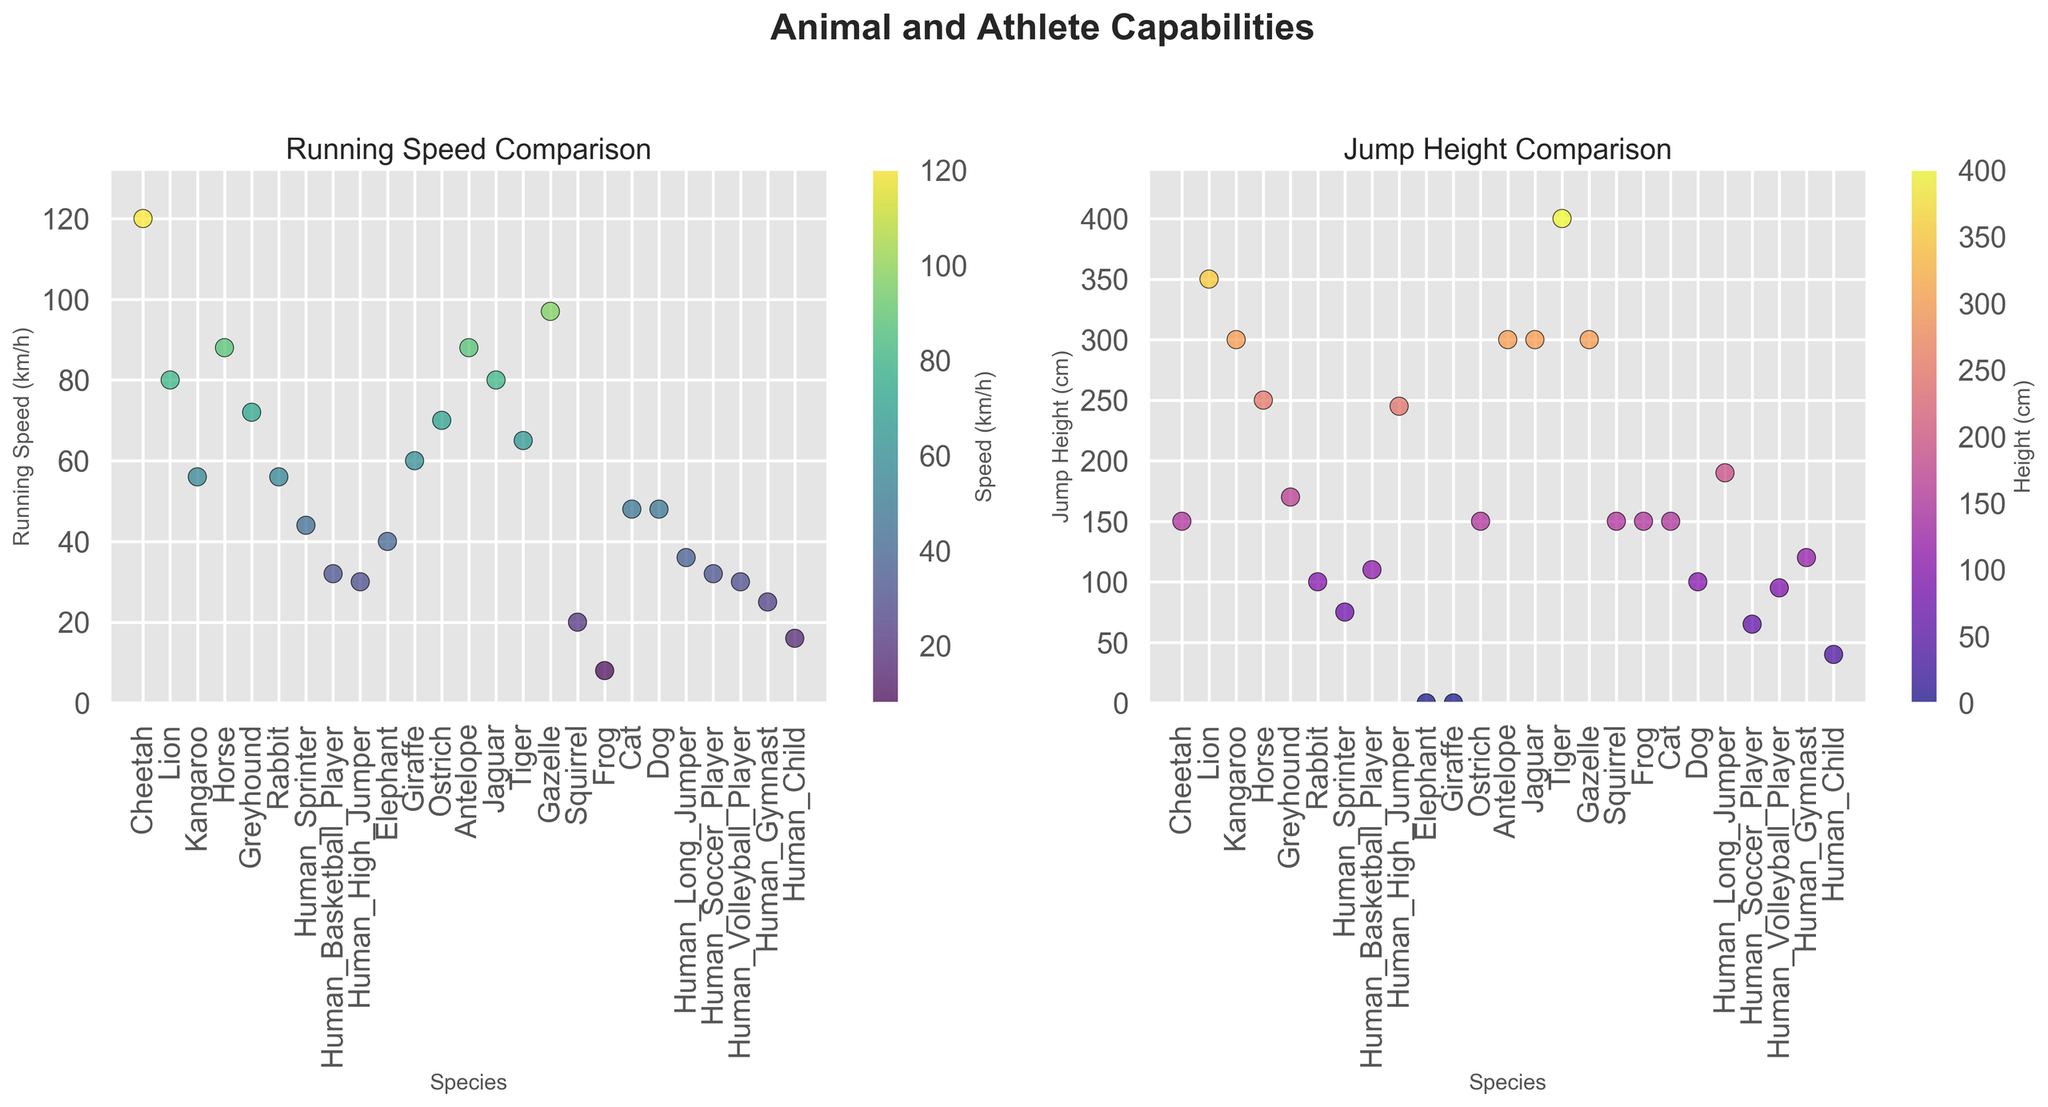Which animal runs the fastest? Look at the scatter plot for Running Speed and find the highest point. The Cheetah has the highest running speed at 120 km/h.
Answer: Cheetah Which human athlete jumps the highest? Check the scatter plot for Jump Height and look for the highest point among the human species. The Human High Jumper jumps the highest at 245 cm.
Answer: Human High Jumper How much faster does a Cheetah run compared to a Rabbit? Find the running speeds of both the Cheetah and the Rabbit from the Running Speed scatter plot. The Cheetah runs at 120 km/h and the Rabbit at 56 km/h. The difference is 120 - 56 = 64 km/h.
Answer: 64 km/h Which species has the same running speed as the Rabbit? On the Running Speed scatter plot, find the point that aligns with the Rabbit's speed of 56 km/h. Both the Kangaroo and the Rabbit have the same running speed of 56 km/h.
Answer: Kangaroo What is the total jump height of a Human Sprinter, Human Long Jumper, and Human High Jumper? Check the Jump Height scatter plot for the heights: Human Sprinter (75 cm), Human Long Jumper (190 cm), and Human High Jumper (245 cm). Add these heights together: 75 + 190 + 245 = 510 cm.
Answer: 510 cm Which is taller: the average jump height of a Kangaroo, Antelope, and Gazelle, or a Horse's jump height? Find the Jump Heights: Kangaroo (300 cm), Antelope (300 cm), and Gazelle (300 cm), and average them: (300 + 300 + 300) / 3 = 300 cm. Compare this to the Horse's jump height of 250 cm.
Answer: Average of Kangaroo, Antelope, Gazelle What’s the color of the highest point in the Running Speed scatter plot? In the Running Speed scatter plot, the highest point is for the Cheetah at 120 km/h. According to the color scale, it is the brightest color in the viridis colormap.
Answer: Bright yellow-green What’s the difference in jump height between a Tiger and a Human Basketball Player? From the Jump Height scatter plot, Tiger jumps 400 cm and a Human Basketball Player jumps 110 cm. The difference is 400 - 110 = 290 cm.
Answer: 290 cm Who runs faster: a Greyhound or an Ostrich? Look at the Running Speed of both: Greyhound runs at 72 km/h and Ostrich at 70 km/h. The Greyhound runs faster.
Answer: Greyhound What’s the combined running speed of a Lion, a Human Soccer Player, and a Horse? Check the Running Speed scatter plot for their speeds: Lion (80 km/h), Human Soccer Player (32 km/h), and Horse (88 km/h). Add them: 80 + 32 + 88 = 200 km/h.
Answer: 200 km/h 